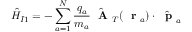<formula> <loc_0><loc_0><loc_500><loc_500>\hat { H } _ { I 1 } = - \sum _ { a = 1 } ^ { N } \frac { q _ { a } } { m _ { a } } \hat { A } _ { T } ( r _ { a } ) \cdot \hat { p } _ { a }</formula> 